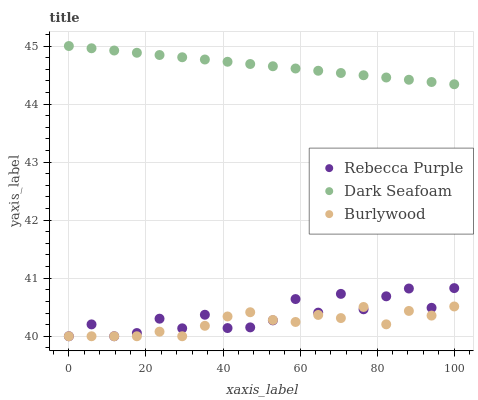Does Burlywood have the minimum area under the curve?
Answer yes or no. Yes. Does Dark Seafoam have the maximum area under the curve?
Answer yes or no. Yes. Does Rebecca Purple have the minimum area under the curve?
Answer yes or no. No. Does Rebecca Purple have the maximum area under the curve?
Answer yes or no. No. Is Dark Seafoam the smoothest?
Answer yes or no. Yes. Is Rebecca Purple the roughest?
Answer yes or no. Yes. Is Rebecca Purple the smoothest?
Answer yes or no. No. Is Dark Seafoam the roughest?
Answer yes or no. No. Does Burlywood have the lowest value?
Answer yes or no. Yes. Does Dark Seafoam have the lowest value?
Answer yes or no. No. Does Dark Seafoam have the highest value?
Answer yes or no. Yes. Does Rebecca Purple have the highest value?
Answer yes or no. No. Is Rebecca Purple less than Dark Seafoam?
Answer yes or no. Yes. Is Dark Seafoam greater than Burlywood?
Answer yes or no. Yes. Does Rebecca Purple intersect Burlywood?
Answer yes or no. Yes. Is Rebecca Purple less than Burlywood?
Answer yes or no. No. Is Rebecca Purple greater than Burlywood?
Answer yes or no. No. Does Rebecca Purple intersect Dark Seafoam?
Answer yes or no. No. 